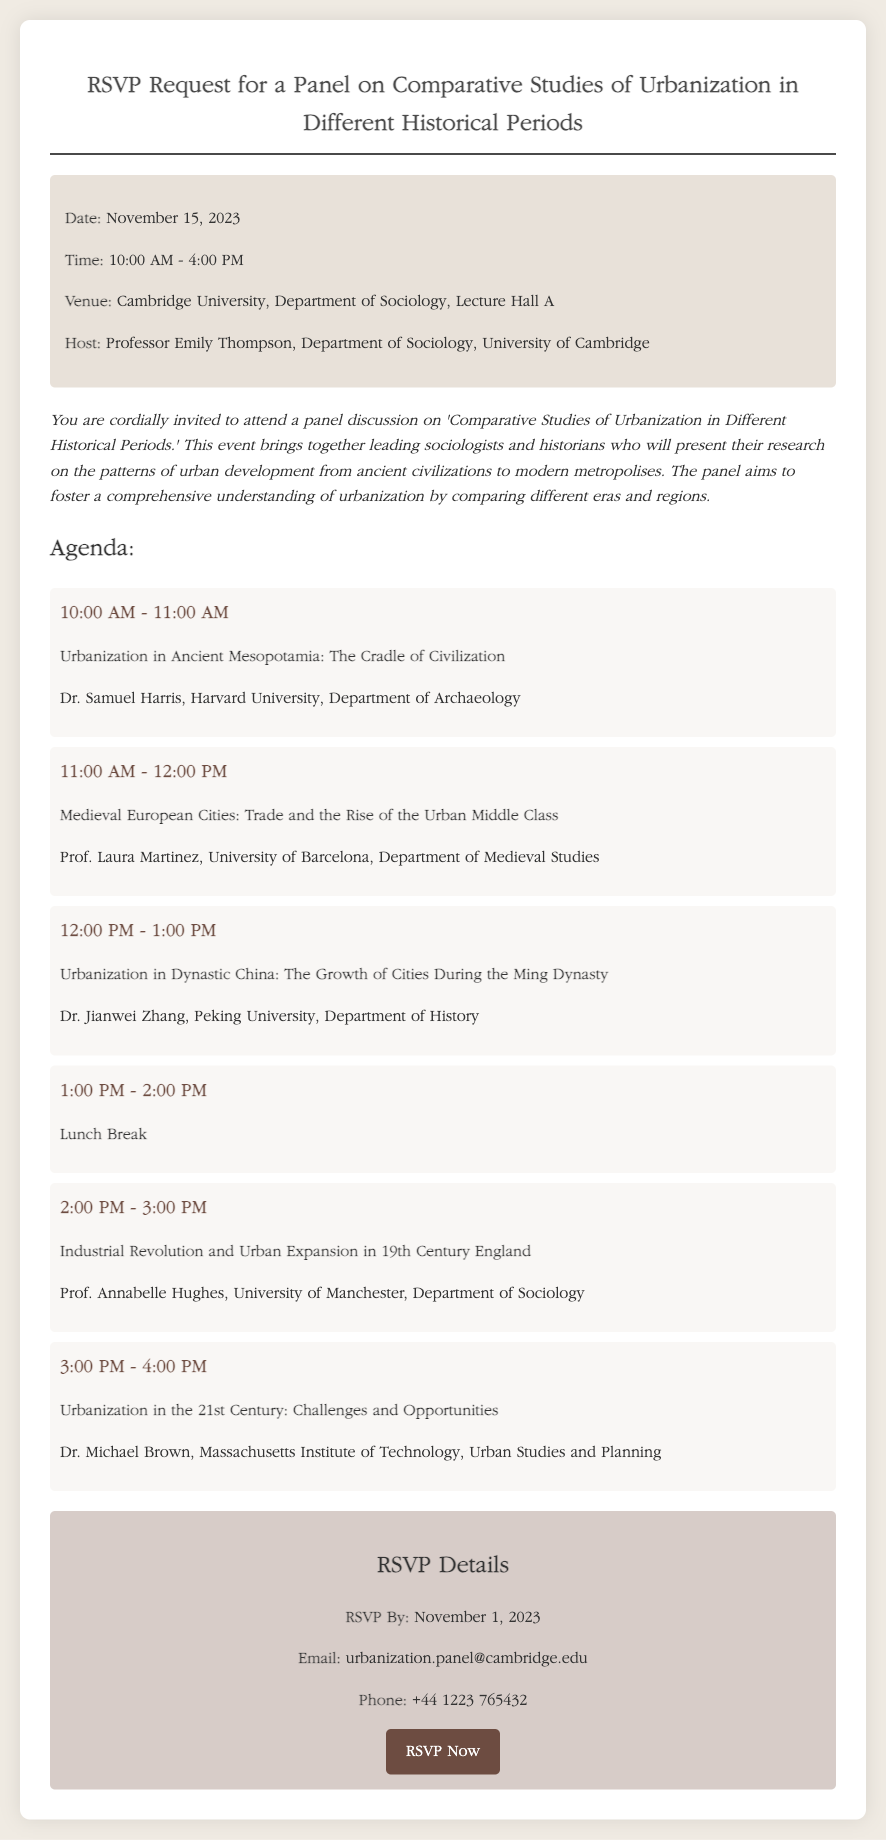What is the date of the panel? The date of the panel is explicitly stated in the event details.
Answer: November 15, 2023 Who is the host of the event? The host's name and affiliation are mentioned in the event details section.
Answer: Professor Emily Thompson What time does the panel start? The starting time of the panel is indicated in the event details.
Answer: 10:00 AM Which university is hosting the panel? The university hosting the panel is mentioned in the venue information.
Answer: Cambridge University What will Dr. Jianwei Zhang present on? Dr. Jianwei Zhang's presentation topic is listed in the agenda.
Answer: Urbanization in Dynastic China: The Growth of Cities During the Ming Dynasty How many agenda items are listed? The total number of agenda items can be counted from the agenda section of the document.
Answer: Six What is the RSVP deadline? The RSVP deadline is specified in the RSVP details section.
Answer: November 1, 2023 What is the phone number provided for RSVPs? The phone number is clearly stated in the RSVP details section.
Answer: +44 1223 765432 What topic does the lunch break fall under in the agenda? The lunch break is identified as an agenda item.
Answer: Lunch Break 